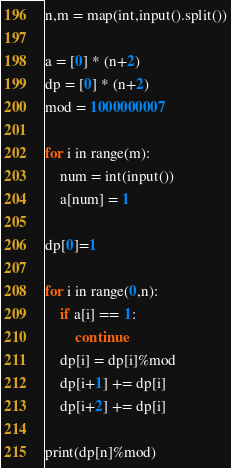<code> <loc_0><loc_0><loc_500><loc_500><_Python_>n,m = map(int,input().split())

a = [0] * (n+2)
dp = [0] * (n+2)
mod = 1000000007

for i in range(m):
	num = int(input())
	a[num] = 1

dp[0]=1

for i in range(0,n):
	if a[i] == 1:
		continue
	dp[i] = dp[i]%mod
	dp[i+1] += dp[i]
	dp[i+2] += dp[i]

print(dp[n]%mod)</code> 